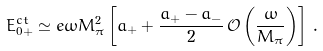Convert formula to latex. <formula><loc_0><loc_0><loc_500><loc_500>E _ { 0 + } ^ { c t } \simeq e \omega M _ { \pi } ^ { 2 } \left [ a _ { + } + \frac { a _ { + } - a _ { - } } { 2 } \, \mathcal { O } \left ( \frac { \omega } { M _ { \pi } } \right ) \right ] \, .</formula> 